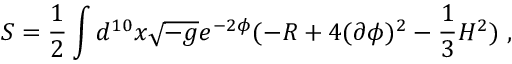<formula> <loc_0><loc_0><loc_500><loc_500>S = \frac { 1 } { 2 } \int d ^ { 1 0 } x \sqrt { - g } e ^ { - 2 \phi } ( - R + 4 ( \partial \phi ) ^ { 2 } - \frac { 1 } { 3 } H ^ { 2 } ) ,</formula> 